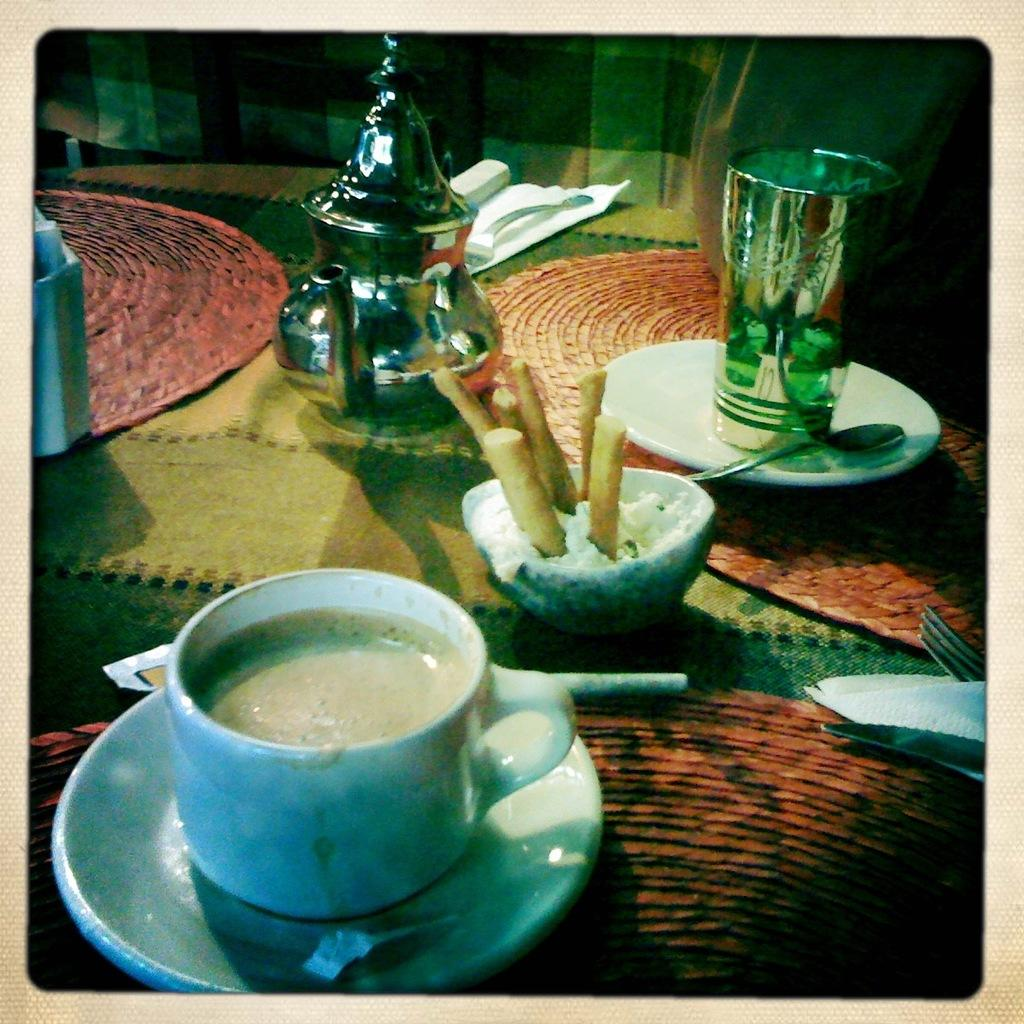What type of furniture is in the image? There is a table in the image. What items are on the table? A cup, a saucer, a bowl, a spoon, a glass, a teapot, a fork, tissue, table mats, and a cloth are on the table. Can you describe the arrangement of the items on the table? The items are arranged on the table, with the cup, saucer, bowl, spoon, glass, and teapot likely forming a place setting, while the tissue, table mats, and cloth are nearby. What type of vegetable is being used as a napkin in the image? There is no vegetable being used as a napkin in the image; the tissue and cloth are used for that purpose. 